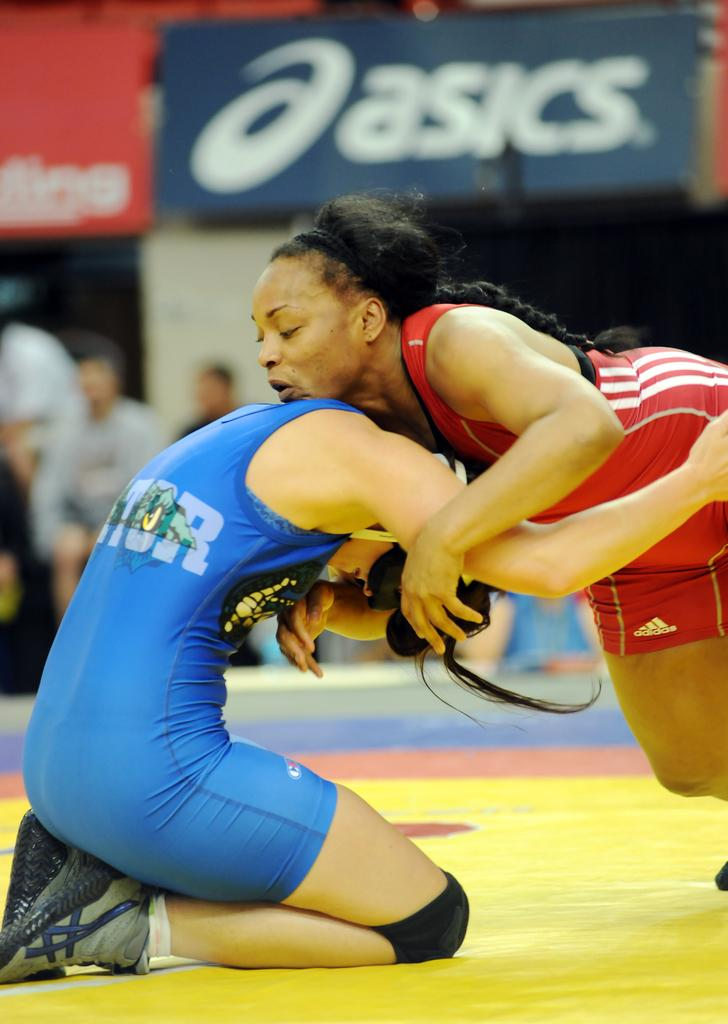<image>
Present a compact description of the photo's key features. one of the sponsors of the game is asics 